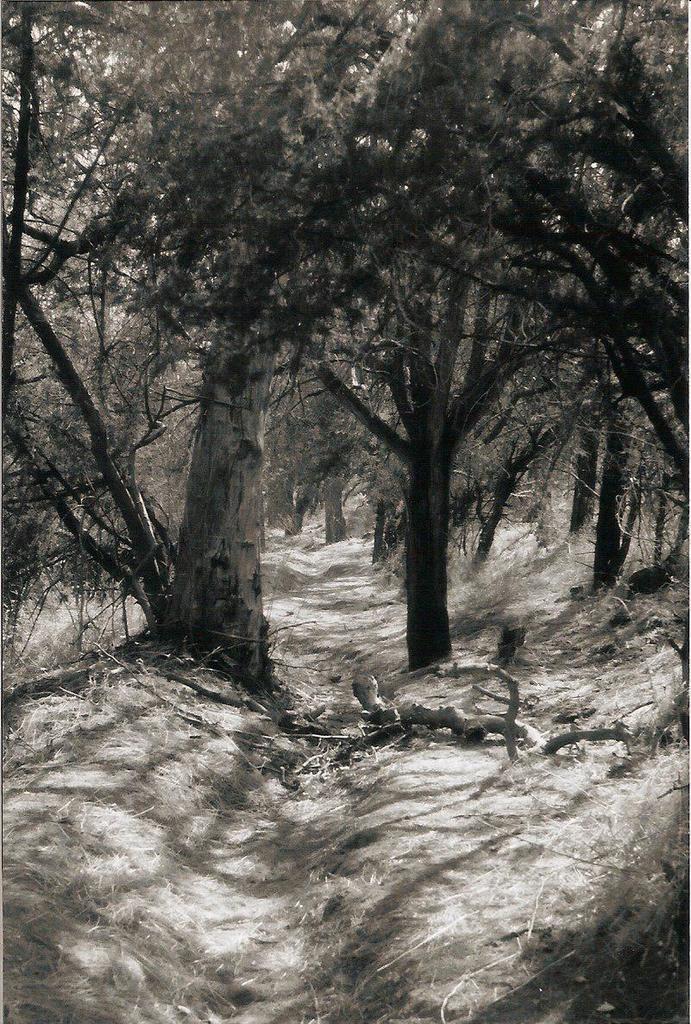Describe this image in one or two sentences. In this image we can see so many trees. The land is covered with dry grass. 